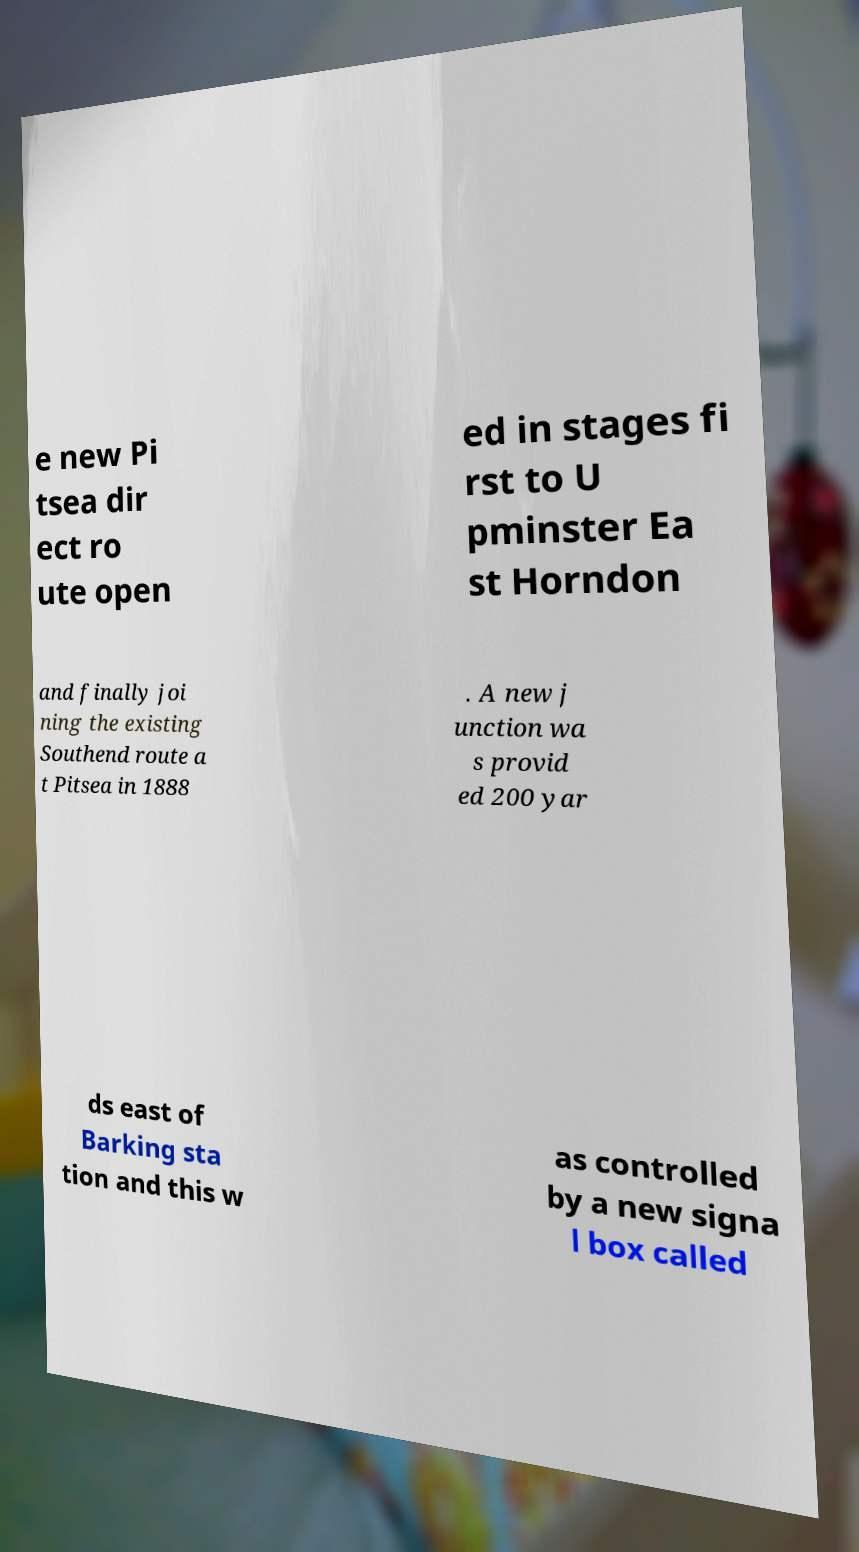Can you read and provide the text displayed in the image?This photo seems to have some interesting text. Can you extract and type it out for me? e new Pi tsea dir ect ro ute open ed in stages fi rst to U pminster Ea st Horndon and finally joi ning the existing Southend route a t Pitsea in 1888 . A new j unction wa s provid ed 200 yar ds east of Barking sta tion and this w as controlled by a new signa l box called 